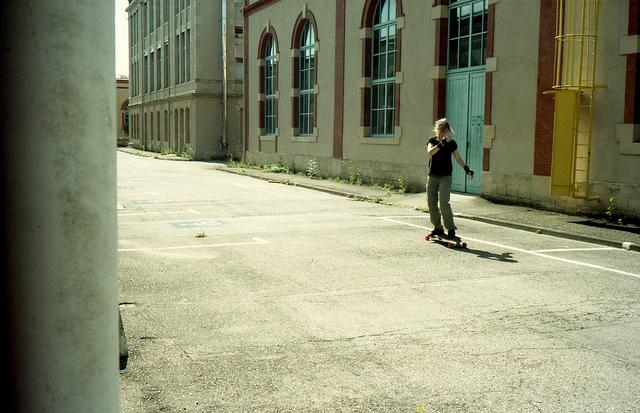What street is this?
Answer briefly. Parking lot. What color is the door?
Be succinct. Blue. What is on the person's hands?
Short answer required. Gloves. Is this an abandoned area?
Give a very brief answer. Yes. What is the person doing?
Answer briefly. Skateboarding. What color is the t-shirt of man on skateboard?
Short answer required. Black. 